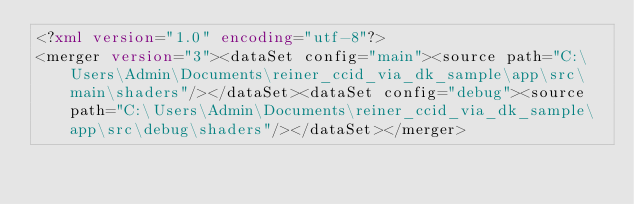Convert code to text. <code><loc_0><loc_0><loc_500><loc_500><_XML_><?xml version="1.0" encoding="utf-8"?>
<merger version="3"><dataSet config="main"><source path="C:\Users\Admin\Documents\reiner_ccid_via_dk_sample\app\src\main\shaders"/></dataSet><dataSet config="debug"><source path="C:\Users\Admin\Documents\reiner_ccid_via_dk_sample\app\src\debug\shaders"/></dataSet></merger></code> 